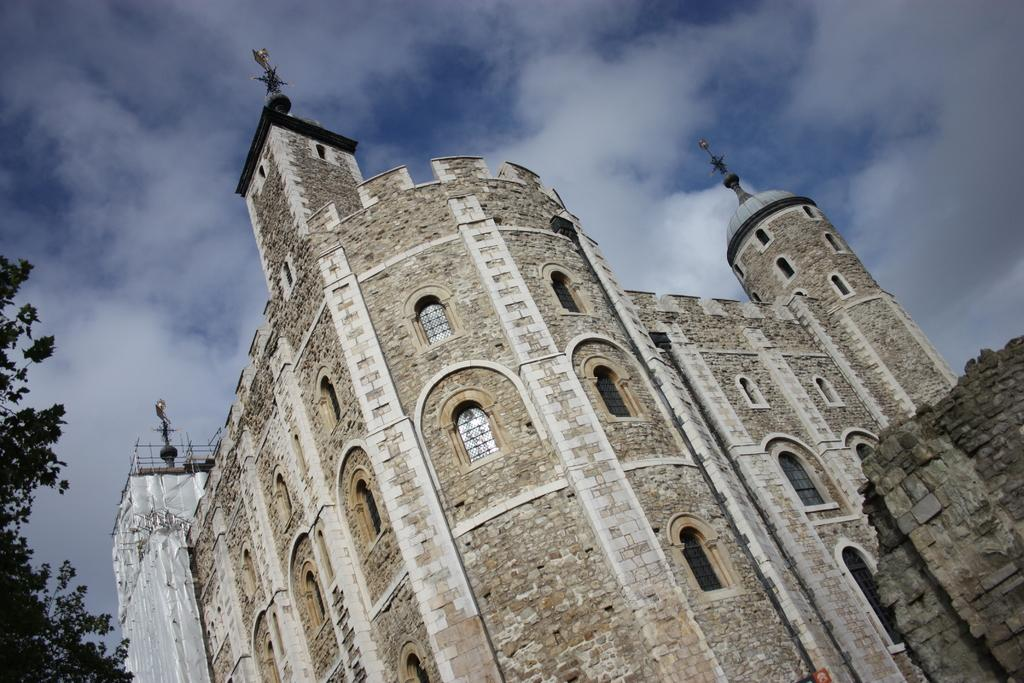What type of structure is present in the image? There is a building in the image. What colors are used for the building? The building is cream and brown in color. What other natural element is present in the image? There is a tree in the image. What is the color of the tree? The tree is green in color. What can be seen in the background of the image? The sky is visible in the background of the image. How many cats are sitting on the wall in the image? There are no cats or walls present in the image. 